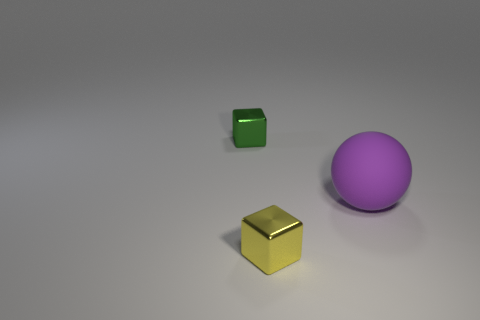There is a green cube that is made of the same material as the yellow object; what is its size?
Provide a short and direct response. Small. What is the size of the shiny cube in front of the tiny thing left of the small metal cube in front of the small green metal object?
Ensure brevity in your answer.  Small. There is a metallic block in front of the green metal cube; how big is it?
Your answer should be very brief. Small. How many purple things are cubes or big cylinders?
Keep it short and to the point. 0. Is there another yellow metallic thing that has the same size as the yellow metal thing?
Offer a terse response. No. There is a yellow block that is the same size as the green metallic thing; what is its material?
Your answer should be very brief. Metal. Is the size of the block that is behind the tiny yellow cube the same as the thing in front of the big purple thing?
Provide a short and direct response. Yes. What number of things are tiny yellow rubber cylinders or objects that are on the left side of the ball?
Your response must be concise. 2. Is there a large purple matte thing that has the same shape as the yellow thing?
Your answer should be compact. No. How big is the object on the left side of the metal block in front of the large rubber thing?
Your answer should be very brief. Small. 